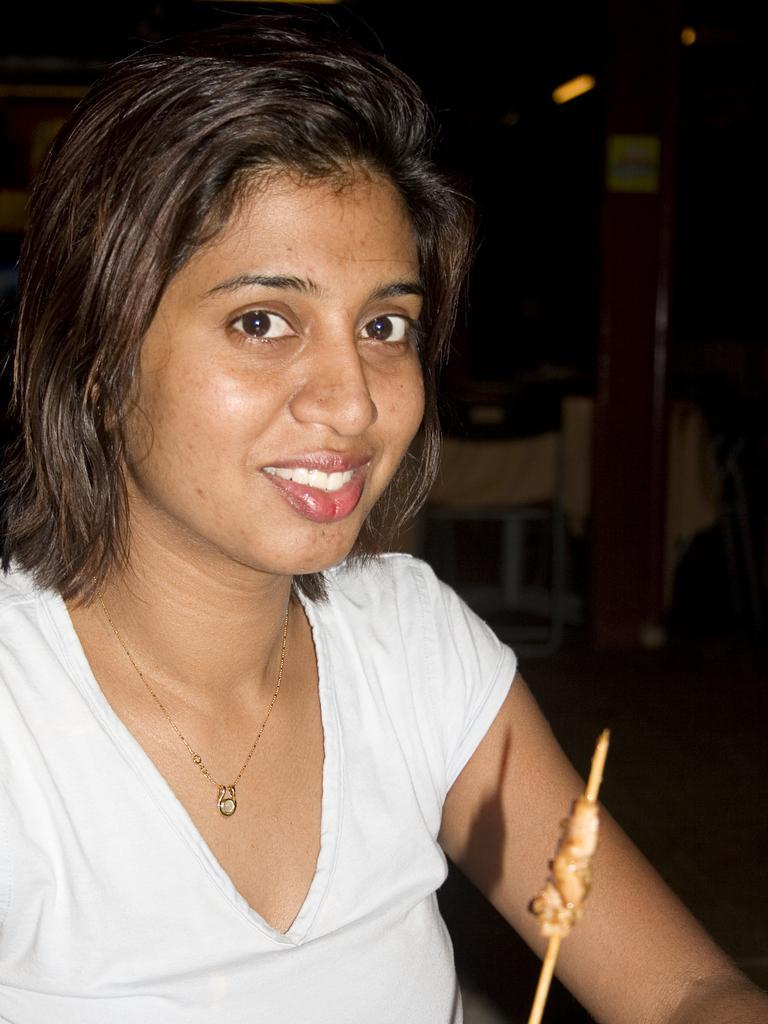Can you describe this image briefly? In the foreground, I can see a woman is sitting on a chair and is holding some object in hand. In the background, I can see a person, pillar, table and dark color. This image might be taken in a hotel. 